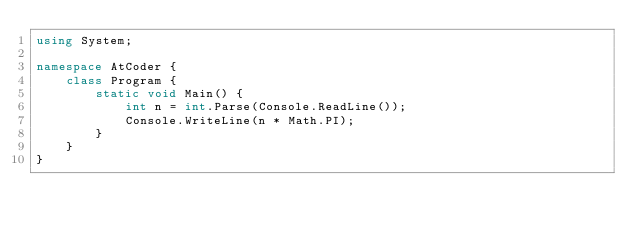Convert code to text. <code><loc_0><loc_0><loc_500><loc_500><_C#_>using System;
 
namespace AtCoder {
    class Program {
        static void Main() {
            int n = int.Parse(Console.ReadLine());
            Console.WriteLine(n * Math.PI);
        }
    }
}</code> 